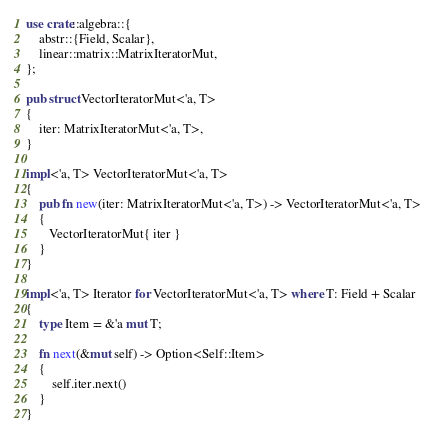<code> <loc_0><loc_0><loc_500><loc_500><_Rust_>use crate::algebra::{
    abstr::{Field, Scalar},
    linear::matrix::MatrixIteratorMut,
};

pub struct VectorIteratorMut<'a, T>
{
    iter: MatrixIteratorMut<'a, T>,
}

impl<'a, T> VectorIteratorMut<'a, T>
{
    pub fn new(iter: MatrixIteratorMut<'a, T>) -> VectorIteratorMut<'a, T>
    {
       VectorIteratorMut{ iter }
    }
}

impl<'a, T> Iterator for VectorIteratorMut<'a, T> where T: Field + Scalar
{
    type Item = &'a mut T;

    fn next(&mut self) -> Option<Self::Item>
    {
        self.iter.next()
    }
}
</code> 